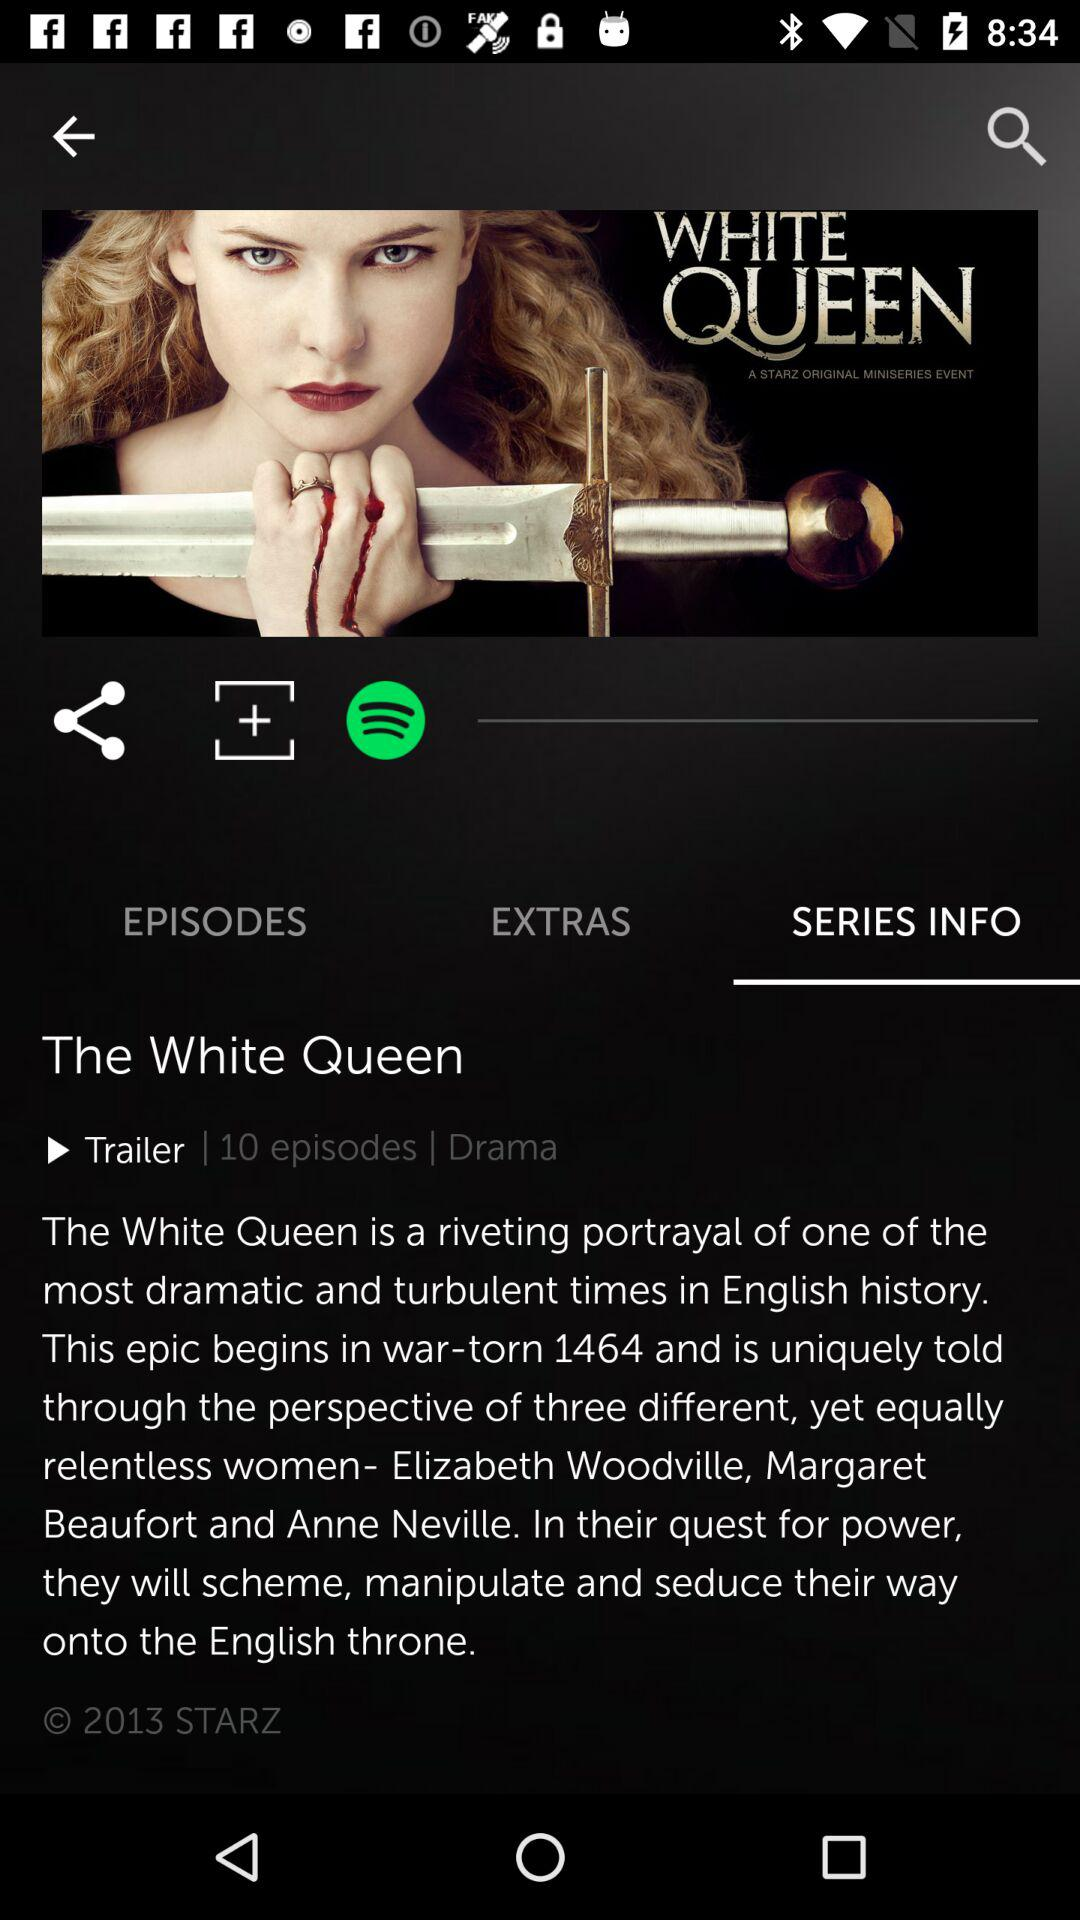How many episodes are there in this series?
Answer the question using a single word or phrase. 10 